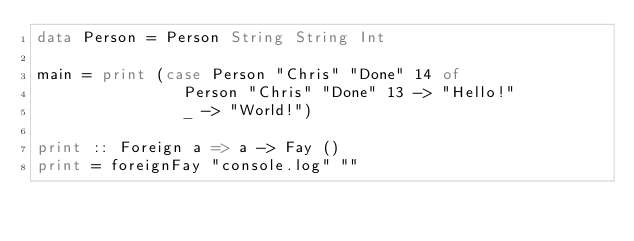<code> <loc_0><loc_0><loc_500><loc_500><_Haskell_>data Person = Person String String Int

main = print (case Person "Chris" "Done" 14 of
                Person "Chris" "Done" 13 -> "Hello!"
                _ -> "World!")

print :: Foreign a => a -> Fay ()
print = foreignFay "console.log" ""
</code> 